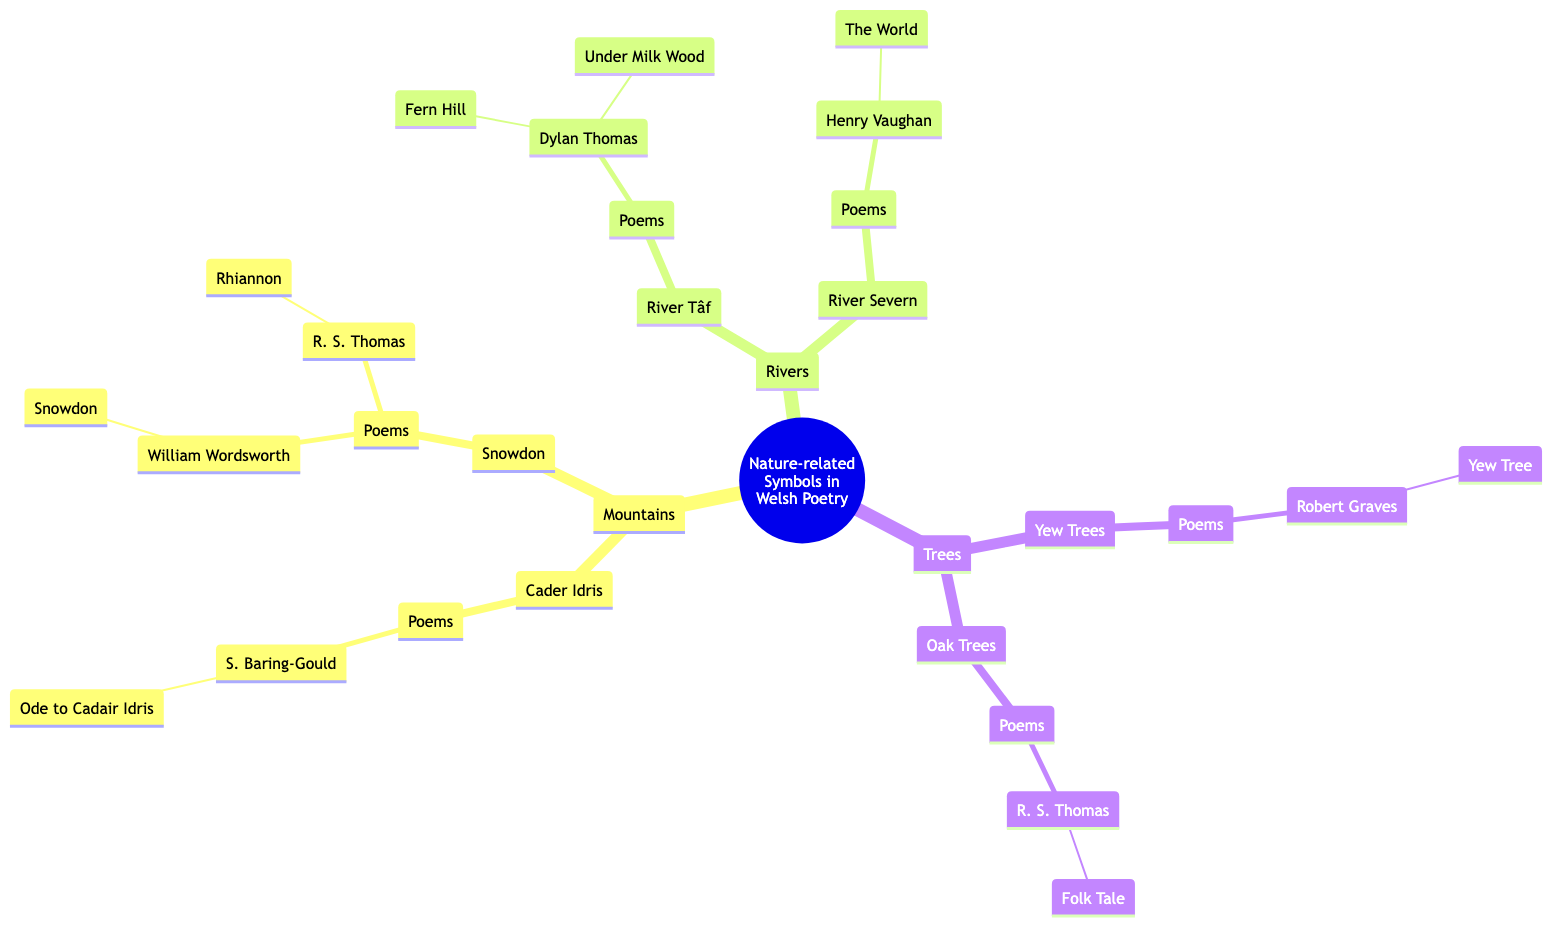What is the first child node of the root? The root of the diagram is "Nature-related Symbols in Welsh Poetry," and the first child node it has is "Mountains."
Answer: Mountains How many major categories are represented in this diagram? There are three major categories listed under the root: "Mountains," "Rivers," and "Trees." Therefore, the total number is three.
Answer: 3 Which poet wrote the poem "Fern Hill"? In the diagram, "Fern Hill" is connected under "River Tâf" with "Dylan Thomas," making him the poet of that work.
Answer: Dylan Thomas What are the yew trees' poems listed in the diagram? According to the diagram, the poem associated with "Yew Trees" is "Yew Tree" written by "Robert Graves."
Answer: Yew Tree Which mountain is featured in William Wordsworth's poetry? The diagram shows that William Wordsworth's poem "Snowdon" is associated with the mountain "Snowdon (Yr Wyddfa)."
Answer: Snowdon Who wrote "Rhiannon"? The diagram indicates that "Rhiannon" is a poem written by "R. S. Thomas," which is under the mountain "Snowdon."
Answer: R. S. Thomas What type of natural element does "Yew Trees" belong to in the diagram? "Yew Trees" is categorized under the major section of "Trees," indicating it is a type of tree representation in the diagram.
Answer: Trees Which river is linked to the poem "The World"? In the diagram, "The World" is linked with "Henry Vaughan," and it falls under the category of "River Severn (Afon Hafren)."
Answer: River Severn How many poems are associated with Cader Idris? The diagram shows that there is one poem linked to "Cader Idris," which is "Ode to Cadair Idris" by "S. Baring-Gould." Thus, the total count is one.
Answer: 1 